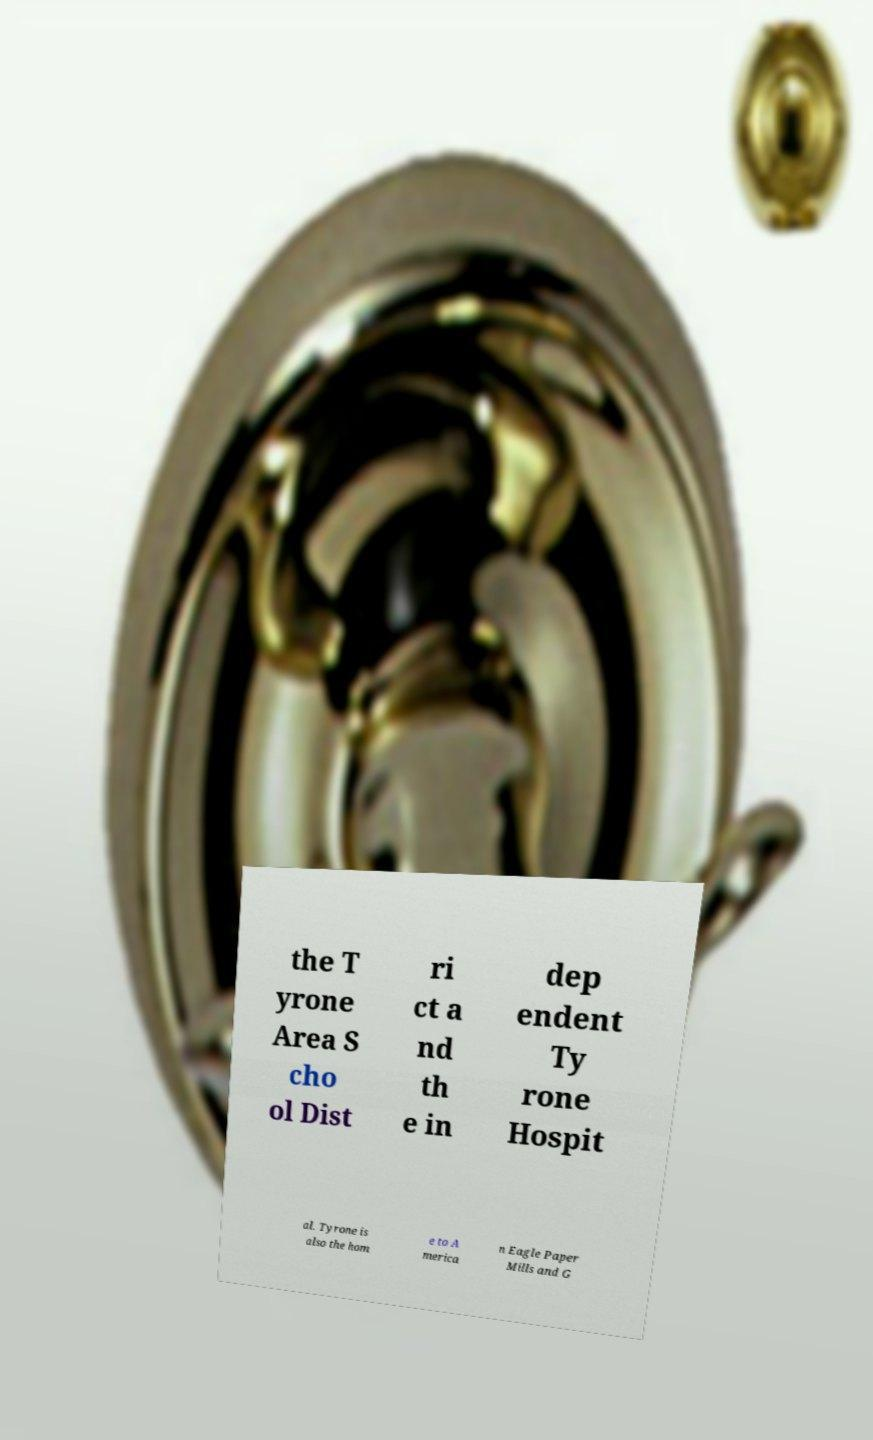There's text embedded in this image that I need extracted. Can you transcribe it verbatim? the T yrone Area S cho ol Dist ri ct a nd th e in dep endent Ty rone Hospit al. Tyrone is also the hom e to A merica n Eagle Paper Mills and G 